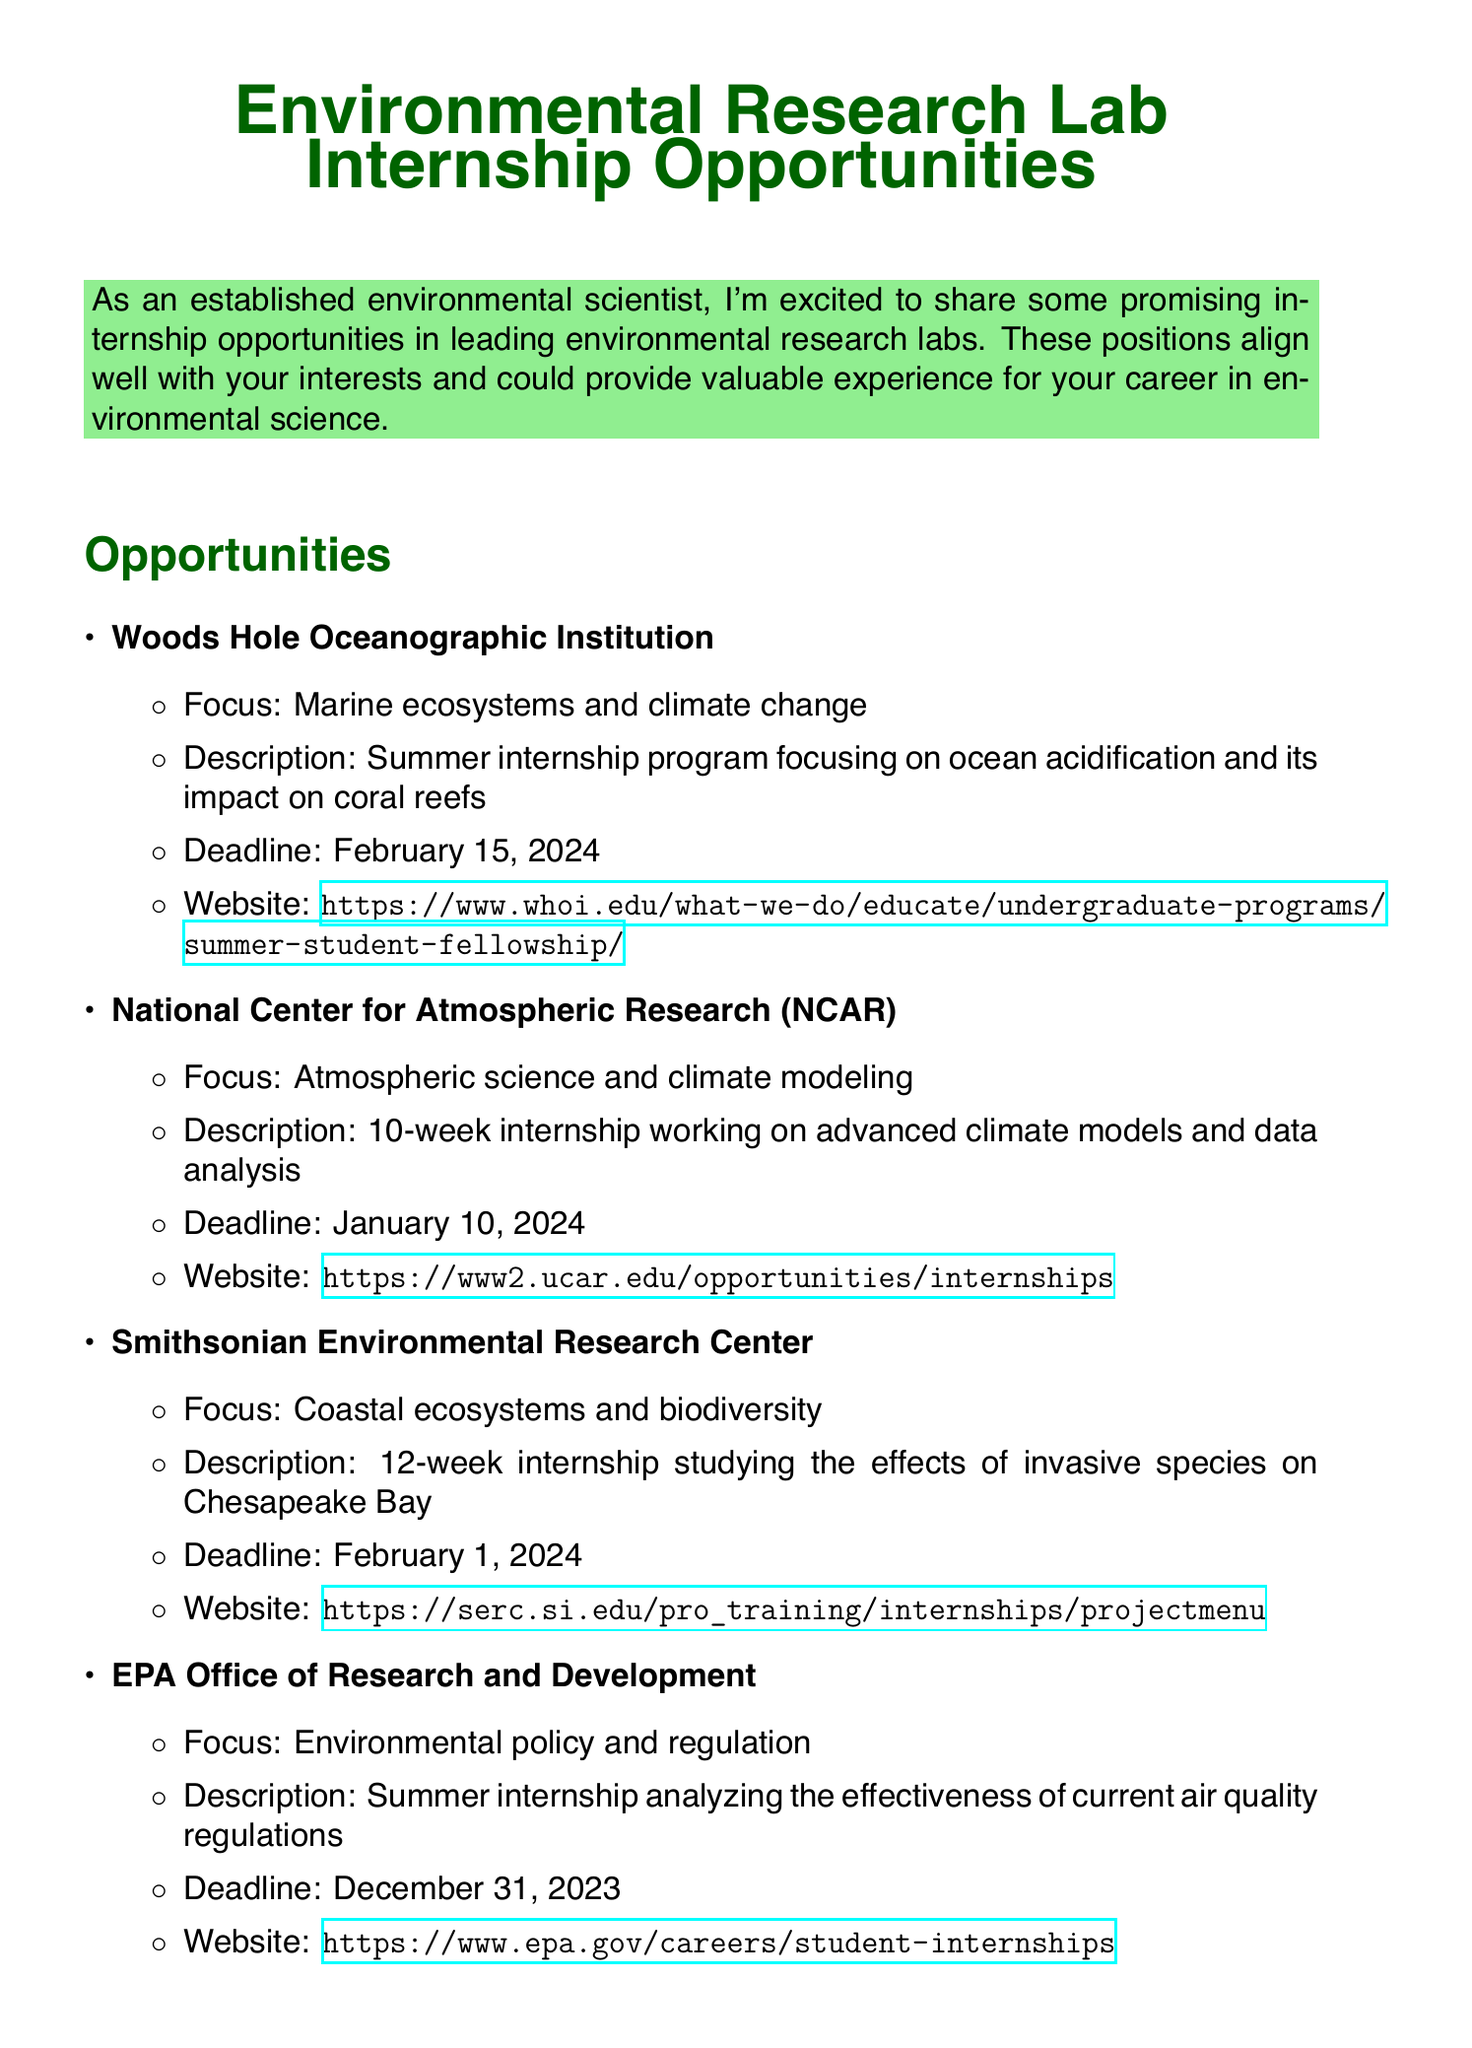what is the application deadline for the Woods Hole Oceanographic Institution internship? The application deadline is specifically stated in the document.
Answer: February 15, 2024 what research focus is associated with the Smithsonian Environmental Research Center internship? The research focus is mentioned in the description of the internship in the document.
Answer: Coastal ecosystems and biodiversity how long is the internship at the National Center for Atmospheric Research? The duration of the internship is clearly noted in the document.
Answer: 10-week what type of research does the EPA Office of Research and Development internship involve? The specific type of research is described under the lab's section in the document.
Answer: Environmental policy and regulation which internship has the earliest application deadline? Comparing the deadlines for all internships in the document helps to identify the earliest one.
Answer: EPA Office of Research and Development which resource is a job board for environmental careers? The additional resources section lists various resources including one specifically mentioned as a job board for environmental careers.
Answer: EcoLeaders Career Center which internship is recommended for someone interested in climate modeling? The personal recommendation section explicitly states which internship aligns with interests in climate modeling.
Answer: NCAR internship how many weeks does the Smithsonian Environmental Research Center internship last? The duration of the internship is mentioned directly in the description.
Answer: 12-week 